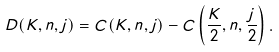<formula> <loc_0><loc_0><loc_500><loc_500>D ( K , n , j ) = C ( K , n , j ) - C \left ( \frac { K } { 2 } , n , \frac { j } { 2 } \right ) .</formula> 